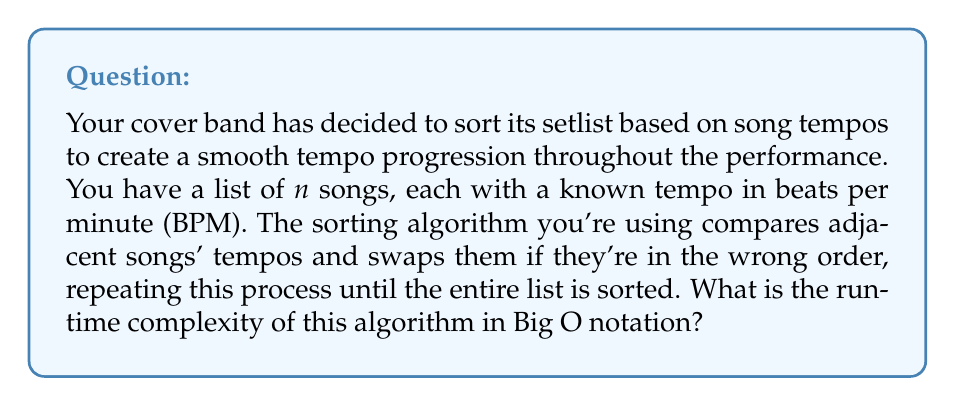Help me with this question. To analyze the runtime complexity of this algorithm, let's break it down step-by-step:

1. The algorithm described is essentially the Bubble Sort algorithm, which is known for its simplicity but not for its efficiency.

2. In Bubble Sort:
   - We start with an unsorted list of $n$ songs.
   - In each pass, we compare adjacent elements (song tempos) and swap them if they're in the wrong order.
   - We repeat this process until no more swaps are needed.

3. In the worst-case scenario (when the list is in reverse order):
   - The outer loop runs $n-1$ times (where $n$ is the number of songs).
   - For each outer loop iteration, the inner loop makes $n-i-1$ comparisons, where $i$ is the current outer loop iteration (0-indexed).

4. The total number of comparisons can be expressed as:

   $$ \sum_{i=0}^{n-2} (n-i-1) = (n-1) + (n-2) + ... + 2 + 1 $$

5. This sum is an arithmetic series that can be simplified to:

   $$ \frac{n(n-1)}{2} $$

6. In Big O notation, we're concerned with the dominant term as $n$ grows large. The $\frac{n^2}{2}$ term dominates, and we drop constants in Big O notation.

Therefore, the runtime complexity of this song sorting algorithm based on tempo is $O(n^2)$.
Answer: $O(n^2)$ 